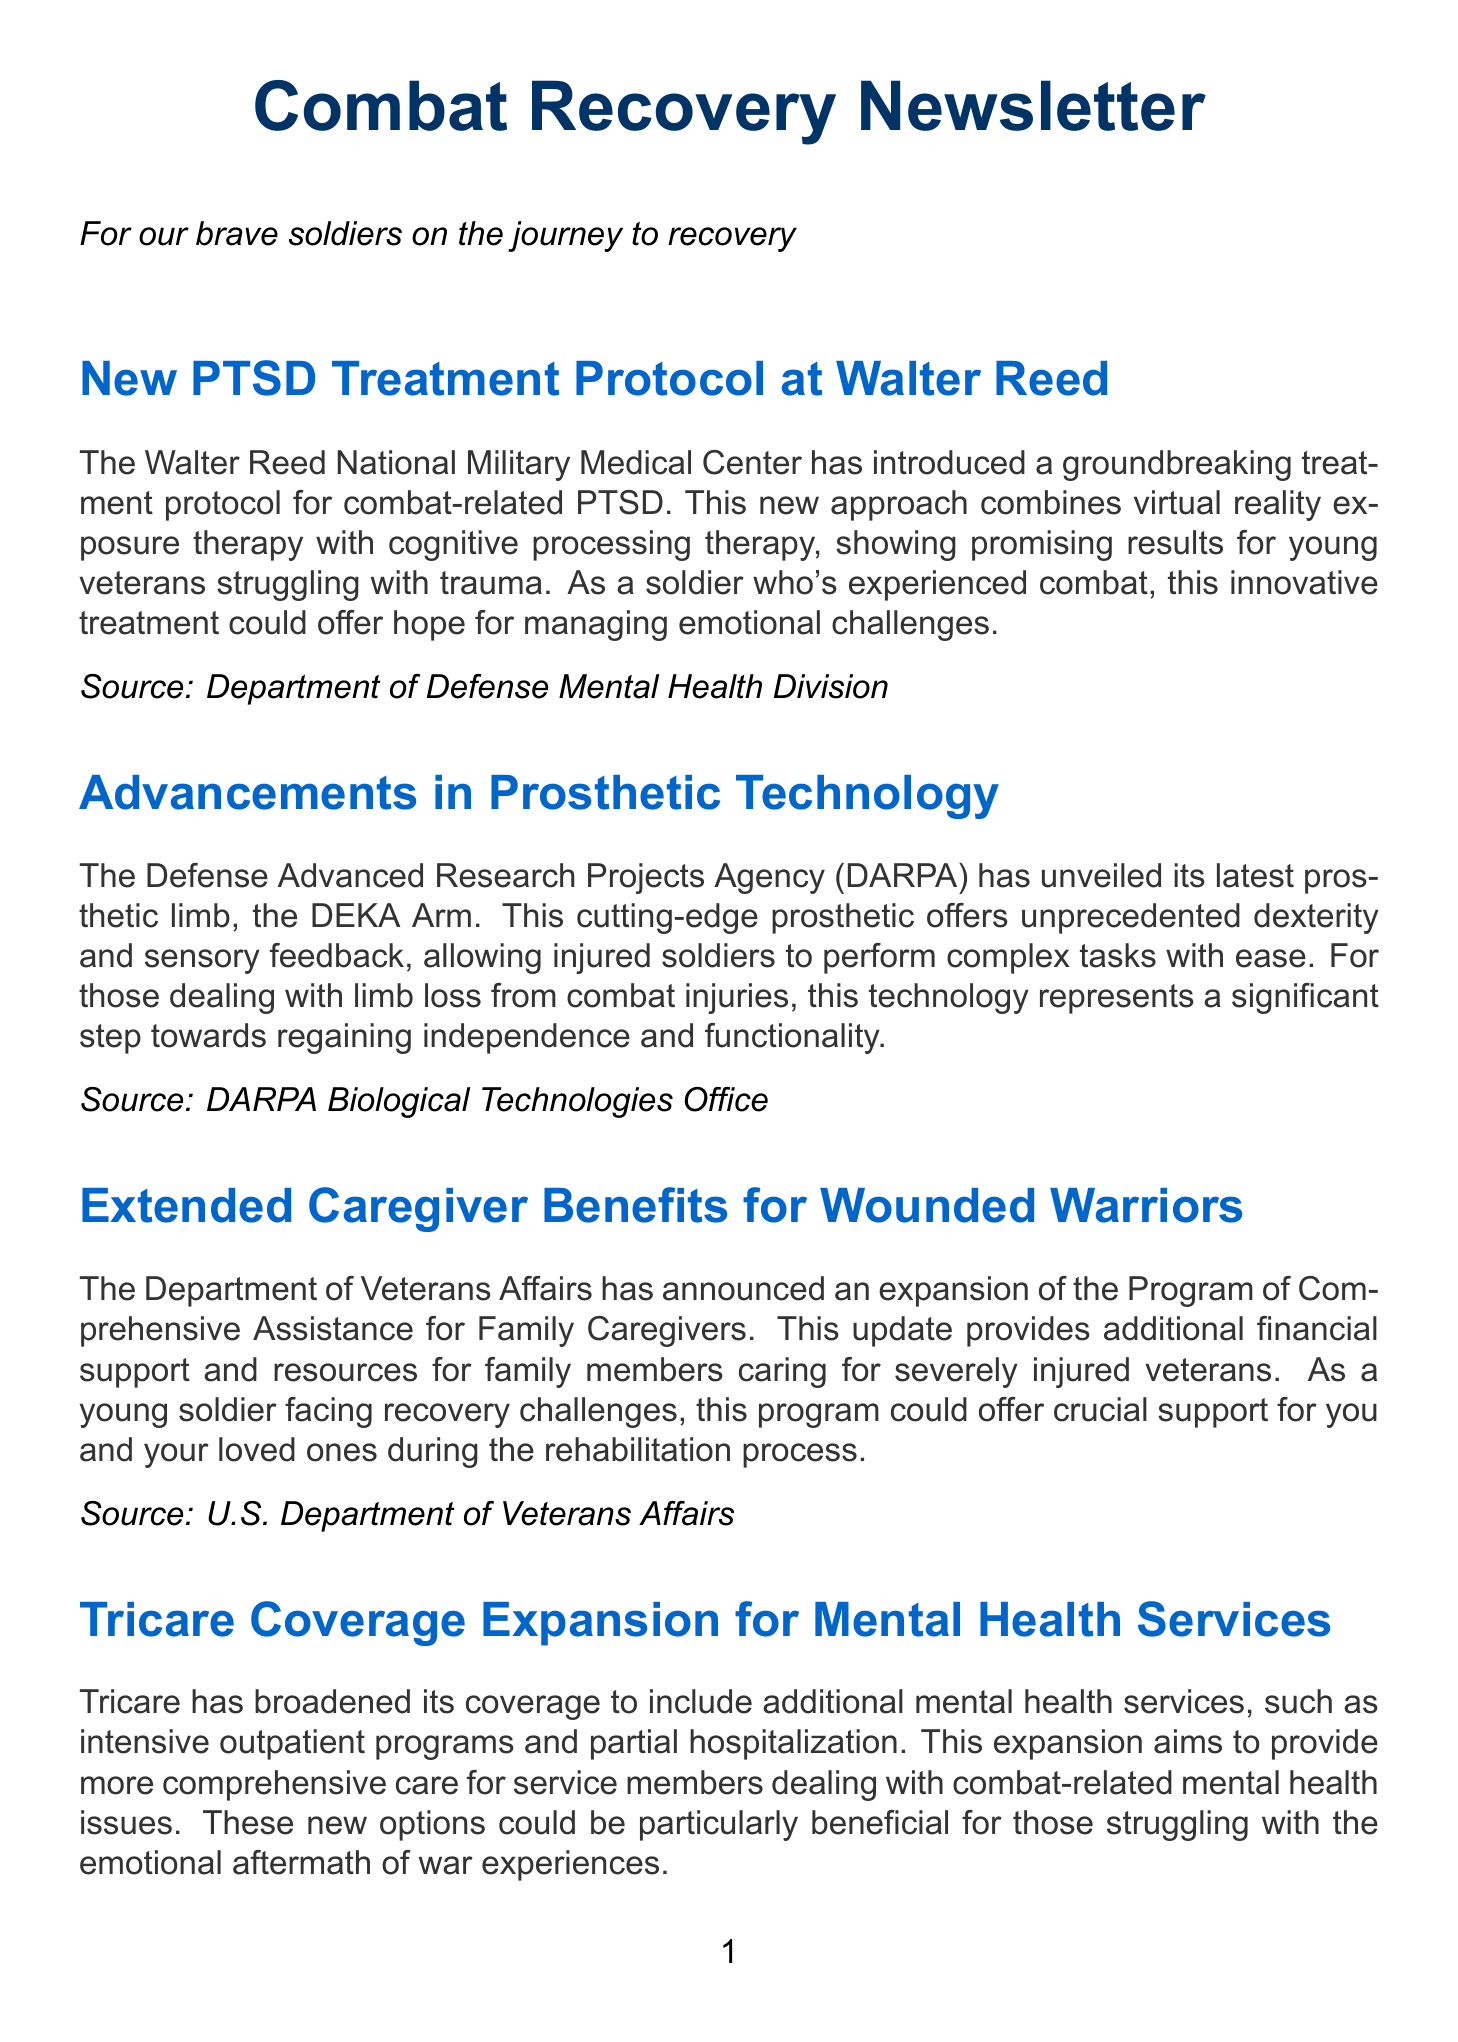What is the new treatment for PTSD? The new treatment for PTSD combines virtual reality exposure therapy with cognitive processing therapy, as described in the newsletter.
Answer: virtual reality exposure therapy with cognitive processing therapy What is the name of the latest prosthetic limb introduced by DARPA? The newsletter mentions the latest prosthetic limb introduced by DARPA as the DEKA Arm.
Answer: DEKA Arm What is the expanded program for caregivers called? The expanded program for caregivers is referred to as the Program of Comprehensive Assistance for Family Caregivers in the document.
Answer: Program of Comprehensive Assistance for Family Caregivers What type of therapy is emphasized in the new pain management guidelines? The new pain management guidelines emphasize non-opioid treatments, including physical therapy, acupuncture, and mindfulness techniques.
Answer: non-opioid treatments What innovative approach is being used for burn injuries? The innovative approach for burn injuries uses a combination of stem cell therapy and advanced wound dressings, as mentioned in the newsletter.
Answer: stem cell therapy and advanced wound dressings How has Tricare expanded its mental health services? Tricare has expanded its mental health services to include additional options such as intensive outpatient programs and partial hospitalization.
Answer: intensive outpatient programs and partial hospitalization What organization is responsible for the new PTSD treatment protocol? The new PTSD treatment protocol is introduced by the Walter Reed National Military Medical Center, according to the newsletter.
Answer: Walter Reed National Military Medical Center 